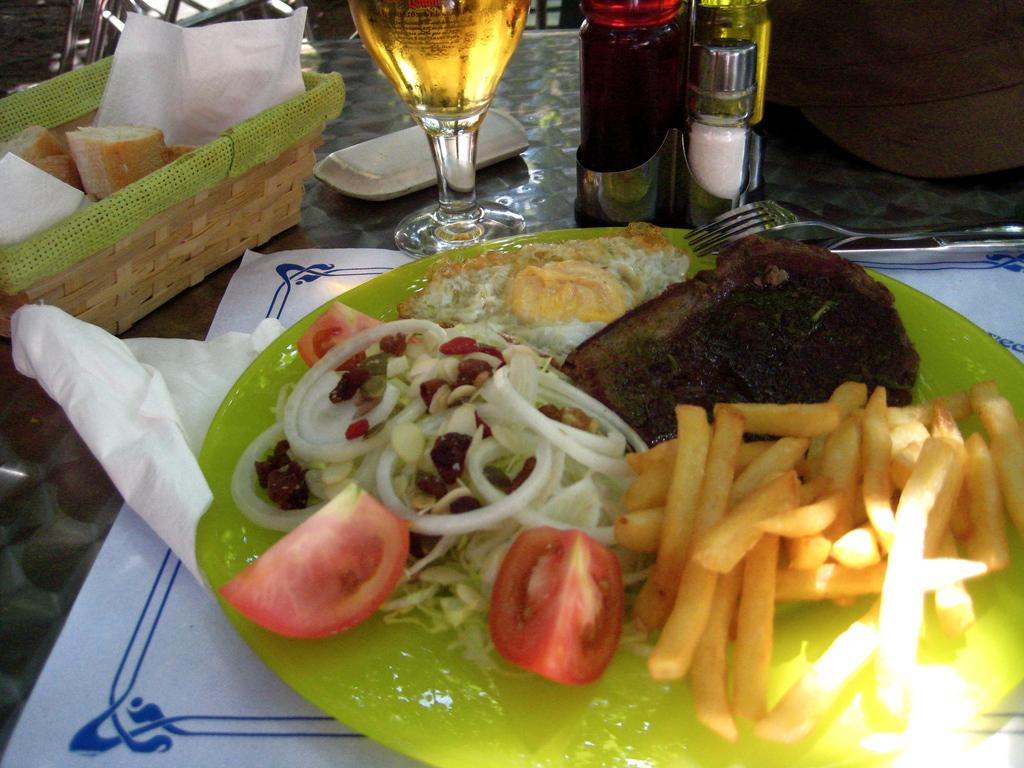What type of food is on the plate in the image? The specific type of food on the plate is not mentioned, but there is food on a plate in the image. What is in the glass on the table? There is wine in the glass on the table. What accompanies the food and wine on the table? There is a basket with pieces of bread on the table. Where are these items located in the image? All these items are on a table. How much powder is needed to pay for the meal in the image? There is no mention of payment or powder in the image; it features food, wine, and bread on a table. 